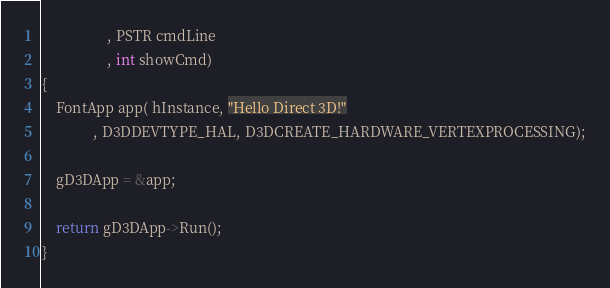Convert code to text. <code><loc_0><loc_0><loc_500><loc_500><_C++_>				  , PSTR cmdLine
				  , int showCmd)
{
	FontApp app( hInstance, "Hello Direct 3D!"
			  , D3DDEVTYPE_HAL, D3DCREATE_HARDWARE_VERTEXPROCESSING);

	gD3DApp = &app;

	return gD3DApp->Run();
}</code> 